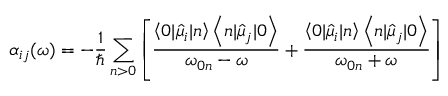<formula> <loc_0><loc_0><loc_500><loc_500>\alpha _ { i j } ( \omega ) = - \frac { 1 } { } \sum _ { n > 0 } \left [ \frac { \left \langle 0 | \hat { \mu } _ { i } | n \right \rangle \left \langle n | \hat { \mu } _ { j } | 0 \right \rangle } { \omega _ { 0 n } - \omega } + \frac { \left \langle 0 | \hat { \mu } _ { i } | n \right \rangle \left \langle n | \hat { \mu } _ { j } | 0 \right \rangle } { \omega _ { 0 n } + \omega } \right ]</formula> 